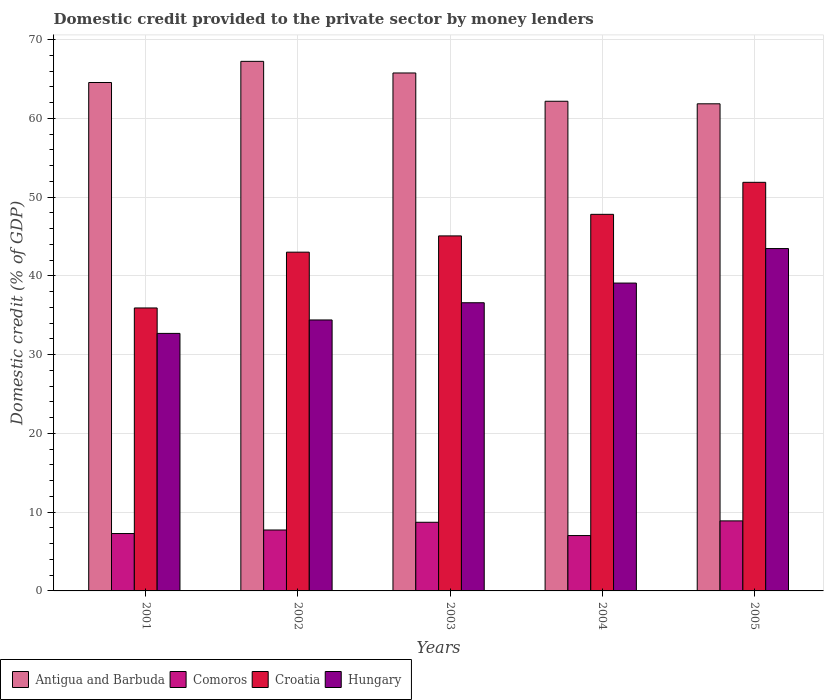How many groups of bars are there?
Your answer should be very brief. 5. Are the number of bars on each tick of the X-axis equal?
Offer a very short reply. Yes. What is the domestic credit provided to the private sector by money lenders in Croatia in 2005?
Your answer should be very brief. 51.88. Across all years, what is the maximum domestic credit provided to the private sector by money lenders in Hungary?
Provide a succinct answer. 43.47. Across all years, what is the minimum domestic credit provided to the private sector by money lenders in Comoros?
Give a very brief answer. 7.03. In which year was the domestic credit provided to the private sector by money lenders in Croatia minimum?
Your answer should be very brief. 2001. What is the total domestic credit provided to the private sector by money lenders in Antigua and Barbuda in the graph?
Keep it short and to the point. 321.6. What is the difference between the domestic credit provided to the private sector by money lenders in Comoros in 2004 and that in 2005?
Make the answer very short. -1.86. What is the difference between the domestic credit provided to the private sector by money lenders in Comoros in 2001 and the domestic credit provided to the private sector by money lenders in Croatia in 2002?
Your answer should be compact. -35.73. What is the average domestic credit provided to the private sector by money lenders in Antigua and Barbuda per year?
Offer a very short reply. 64.32. In the year 2001, what is the difference between the domestic credit provided to the private sector by money lenders in Hungary and domestic credit provided to the private sector by money lenders in Croatia?
Ensure brevity in your answer.  -3.23. In how many years, is the domestic credit provided to the private sector by money lenders in Hungary greater than 66 %?
Offer a very short reply. 0. What is the ratio of the domestic credit provided to the private sector by money lenders in Antigua and Barbuda in 2001 to that in 2005?
Offer a very short reply. 1.04. What is the difference between the highest and the second highest domestic credit provided to the private sector by money lenders in Croatia?
Your answer should be compact. 4.07. What is the difference between the highest and the lowest domestic credit provided to the private sector by money lenders in Comoros?
Give a very brief answer. 1.86. Is it the case that in every year, the sum of the domestic credit provided to the private sector by money lenders in Antigua and Barbuda and domestic credit provided to the private sector by money lenders in Croatia is greater than the sum of domestic credit provided to the private sector by money lenders in Comoros and domestic credit provided to the private sector by money lenders in Hungary?
Your answer should be compact. Yes. What does the 2nd bar from the left in 2001 represents?
Your answer should be compact. Comoros. What does the 1st bar from the right in 2005 represents?
Ensure brevity in your answer.  Hungary. Is it the case that in every year, the sum of the domestic credit provided to the private sector by money lenders in Antigua and Barbuda and domestic credit provided to the private sector by money lenders in Hungary is greater than the domestic credit provided to the private sector by money lenders in Comoros?
Provide a short and direct response. Yes. How many bars are there?
Offer a terse response. 20. Are all the bars in the graph horizontal?
Give a very brief answer. No. Are the values on the major ticks of Y-axis written in scientific E-notation?
Offer a very short reply. No. Where does the legend appear in the graph?
Provide a short and direct response. Bottom left. What is the title of the graph?
Your answer should be very brief. Domestic credit provided to the private sector by money lenders. What is the label or title of the Y-axis?
Your answer should be very brief. Domestic credit (% of GDP). What is the Domestic credit (% of GDP) in Antigua and Barbuda in 2001?
Your answer should be very brief. 64.56. What is the Domestic credit (% of GDP) of Comoros in 2001?
Offer a terse response. 7.29. What is the Domestic credit (% of GDP) in Croatia in 2001?
Your answer should be very brief. 35.93. What is the Domestic credit (% of GDP) of Hungary in 2001?
Your answer should be compact. 32.7. What is the Domestic credit (% of GDP) of Antigua and Barbuda in 2002?
Provide a short and direct response. 67.24. What is the Domestic credit (% of GDP) of Comoros in 2002?
Your answer should be very brief. 7.74. What is the Domestic credit (% of GDP) in Croatia in 2002?
Keep it short and to the point. 43.01. What is the Domestic credit (% of GDP) in Hungary in 2002?
Provide a succinct answer. 34.41. What is the Domestic credit (% of GDP) of Antigua and Barbuda in 2003?
Your answer should be compact. 65.77. What is the Domestic credit (% of GDP) of Comoros in 2003?
Offer a very short reply. 8.72. What is the Domestic credit (% of GDP) in Croatia in 2003?
Give a very brief answer. 45.08. What is the Domestic credit (% of GDP) in Hungary in 2003?
Provide a short and direct response. 36.59. What is the Domestic credit (% of GDP) of Antigua and Barbuda in 2004?
Ensure brevity in your answer.  62.18. What is the Domestic credit (% of GDP) of Comoros in 2004?
Offer a very short reply. 7.03. What is the Domestic credit (% of GDP) of Croatia in 2004?
Ensure brevity in your answer.  47.82. What is the Domestic credit (% of GDP) of Hungary in 2004?
Your answer should be compact. 39.09. What is the Domestic credit (% of GDP) in Antigua and Barbuda in 2005?
Your response must be concise. 61.85. What is the Domestic credit (% of GDP) in Comoros in 2005?
Your answer should be very brief. 8.89. What is the Domestic credit (% of GDP) in Croatia in 2005?
Your response must be concise. 51.88. What is the Domestic credit (% of GDP) of Hungary in 2005?
Provide a short and direct response. 43.47. Across all years, what is the maximum Domestic credit (% of GDP) in Antigua and Barbuda?
Offer a terse response. 67.24. Across all years, what is the maximum Domestic credit (% of GDP) in Comoros?
Ensure brevity in your answer.  8.89. Across all years, what is the maximum Domestic credit (% of GDP) in Croatia?
Your answer should be very brief. 51.88. Across all years, what is the maximum Domestic credit (% of GDP) of Hungary?
Offer a terse response. 43.47. Across all years, what is the minimum Domestic credit (% of GDP) in Antigua and Barbuda?
Provide a short and direct response. 61.85. Across all years, what is the minimum Domestic credit (% of GDP) of Comoros?
Provide a succinct answer. 7.03. Across all years, what is the minimum Domestic credit (% of GDP) of Croatia?
Your answer should be very brief. 35.93. Across all years, what is the minimum Domestic credit (% of GDP) in Hungary?
Provide a short and direct response. 32.7. What is the total Domestic credit (% of GDP) in Antigua and Barbuda in the graph?
Offer a terse response. 321.6. What is the total Domestic credit (% of GDP) of Comoros in the graph?
Keep it short and to the point. 39.66. What is the total Domestic credit (% of GDP) in Croatia in the graph?
Keep it short and to the point. 223.72. What is the total Domestic credit (% of GDP) in Hungary in the graph?
Give a very brief answer. 186.26. What is the difference between the Domestic credit (% of GDP) of Antigua and Barbuda in 2001 and that in 2002?
Provide a short and direct response. -2.69. What is the difference between the Domestic credit (% of GDP) of Comoros in 2001 and that in 2002?
Make the answer very short. -0.45. What is the difference between the Domestic credit (% of GDP) of Croatia in 2001 and that in 2002?
Provide a short and direct response. -7.08. What is the difference between the Domestic credit (% of GDP) in Hungary in 2001 and that in 2002?
Ensure brevity in your answer.  -1.71. What is the difference between the Domestic credit (% of GDP) of Antigua and Barbuda in 2001 and that in 2003?
Offer a very short reply. -1.21. What is the difference between the Domestic credit (% of GDP) in Comoros in 2001 and that in 2003?
Offer a terse response. -1.43. What is the difference between the Domestic credit (% of GDP) of Croatia in 2001 and that in 2003?
Your response must be concise. -9.15. What is the difference between the Domestic credit (% of GDP) of Hungary in 2001 and that in 2003?
Provide a succinct answer. -3.89. What is the difference between the Domestic credit (% of GDP) in Antigua and Barbuda in 2001 and that in 2004?
Provide a succinct answer. 2.38. What is the difference between the Domestic credit (% of GDP) of Comoros in 2001 and that in 2004?
Your answer should be very brief. 0.26. What is the difference between the Domestic credit (% of GDP) of Croatia in 2001 and that in 2004?
Provide a succinct answer. -11.89. What is the difference between the Domestic credit (% of GDP) in Hungary in 2001 and that in 2004?
Keep it short and to the point. -6.39. What is the difference between the Domestic credit (% of GDP) in Antigua and Barbuda in 2001 and that in 2005?
Make the answer very short. 2.7. What is the difference between the Domestic credit (% of GDP) in Comoros in 2001 and that in 2005?
Ensure brevity in your answer.  -1.61. What is the difference between the Domestic credit (% of GDP) of Croatia in 2001 and that in 2005?
Offer a terse response. -15.95. What is the difference between the Domestic credit (% of GDP) of Hungary in 2001 and that in 2005?
Give a very brief answer. -10.77. What is the difference between the Domestic credit (% of GDP) of Antigua and Barbuda in 2002 and that in 2003?
Your answer should be compact. 1.47. What is the difference between the Domestic credit (% of GDP) of Comoros in 2002 and that in 2003?
Provide a short and direct response. -0.98. What is the difference between the Domestic credit (% of GDP) of Croatia in 2002 and that in 2003?
Provide a succinct answer. -2.07. What is the difference between the Domestic credit (% of GDP) of Hungary in 2002 and that in 2003?
Your answer should be compact. -2.19. What is the difference between the Domestic credit (% of GDP) of Antigua and Barbuda in 2002 and that in 2004?
Provide a succinct answer. 5.07. What is the difference between the Domestic credit (% of GDP) of Comoros in 2002 and that in 2004?
Offer a very short reply. 0.71. What is the difference between the Domestic credit (% of GDP) of Croatia in 2002 and that in 2004?
Your response must be concise. -4.8. What is the difference between the Domestic credit (% of GDP) of Hungary in 2002 and that in 2004?
Offer a very short reply. -4.68. What is the difference between the Domestic credit (% of GDP) of Antigua and Barbuda in 2002 and that in 2005?
Your response must be concise. 5.39. What is the difference between the Domestic credit (% of GDP) of Comoros in 2002 and that in 2005?
Your response must be concise. -1.16. What is the difference between the Domestic credit (% of GDP) in Croatia in 2002 and that in 2005?
Offer a very short reply. -8.87. What is the difference between the Domestic credit (% of GDP) in Hungary in 2002 and that in 2005?
Give a very brief answer. -9.07. What is the difference between the Domestic credit (% of GDP) in Antigua and Barbuda in 2003 and that in 2004?
Keep it short and to the point. 3.59. What is the difference between the Domestic credit (% of GDP) of Comoros in 2003 and that in 2004?
Your answer should be very brief. 1.69. What is the difference between the Domestic credit (% of GDP) of Croatia in 2003 and that in 2004?
Provide a succinct answer. -2.74. What is the difference between the Domestic credit (% of GDP) in Hungary in 2003 and that in 2004?
Give a very brief answer. -2.5. What is the difference between the Domestic credit (% of GDP) in Antigua and Barbuda in 2003 and that in 2005?
Your answer should be very brief. 3.91. What is the difference between the Domestic credit (% of GDP) in Comoros in 2003 and that in 2005?
Keep it short and to the point. -0.18. What is the difference between the Domestic credit (% of GDP) of Croatia in 2003 and that in 2005?
Provide a succinct answer. -6.8. What is the difference between the Domestic credit (% of GDP) in Hungary in 2003 and that in 2005?
Keep it short and to the point. -6.88. What is the difference between the Domestic credit (% of GDP) of Antigua and Barbuda in 2004 and that in 2005?
Keep it short and to the point. 0.32. What is the difference between the Domestic credit (% of GDP) of Comoros in 2004 and that in 2005?
Offer a very short reply. -1.86. What is the difference between the Domestic credit (% of GDP) in Croatia in 2004 and that in 2005?
Ensure brevity in your answer.  -4.07. What is the difference between the Domestic credit (% of GDP) of Hungary in 2004 and that in 2005?
Provide a succinct answer. -4.38. What is the difference between the Domestic credit (% of GDP) in Antigua and Barbuda in 2001 and the Domestic credit (% of GDP) in Comoros in 2002?
Ensure brevity in your answer.  56.82. What is the difference between the Domestic credit (% of GDP) of Antigua and Barbuda in 2001 and the Domestic credit (% of GDP) of Croatia in 2002?
Give a very brief answer. 21.54. What is the difference between the Domestic credit (% of GDP) of Antigua and Barbuda in 2001 and the Domestic credit (% of GDP) of Hungary in 2002?
Provide a succinct answer. 30.15. What is the difference between the Domestic credit (% of GDP) in Comoros in 2001 and the Domestic credit (% of GDP) in Croatia in 2002?
Provide a succinct answer. -35.73. What is the difference between the Domestic credit (% of GDP) of Comoros in 2001 and the Domestic credit (% of GDP) of Hungary in 2002?
Ensure brevity in your answer.  -27.12. What is the difference between the Domestic credit (% of GDP) in Croatia in 2001 and the Domestic credit (% of GDP) in Hungary in 2002?
Your answer should be very brief. 1.52. What is the difference between the Domestic credit (% of GDP) in Antigua and Barbuda in 2001 and the Domestic credit (% of GDP) in Comoros in 2003?
Make the answer very short. 55.84. What is the difference between the Domestic credit (% of GDP) of Antigua and Barbuda in 2001 and the Domestic credit (% of GDP) of Croatia in 2003?
Your answer should be very brief. 19.48. What is the difference between the Domestic credit (% of GDP) of Antigua and Barbuda in 2001 and the Domestic credit (% of GDP) of Hungary in 2003?
Offer a very short reply. 27.96. What is the difference between the Domestic credit (% of GDP) of Comoros in 2001 and the Domestic credit (% of GDP) of Croatia in 2003?
Make the answer very short. -37.79. What is the difference between the Domestic credit (% of GDP) of Comoros in 2001 and the Domestic credit (% of GDP) of Hungary in 2003?
Offer a very short reply. -29.31. What is the difference between the Domestic credit (% of GDP) of Croatia in 2001 and the Domestic credit (% of GDP) of Hungary in 2003?
Provide a short and direct response. -0.66. What is the difference between the Domestic credit (% of GDP) in Antigua and Barbuda in 2001 and the Domestic credit (% of GDP) in Comoros in 2004?
Provide a succinct answer. 57.53. What is the difference between the Domestic credit (% of GDP) of Antigua and Barbuda in 2001 and the Domestic credit (% of GDP) of Croatia in 2004?
Give a very brief answer. 16.74. What is the difference between the Domestic credit (% of GDP) in Antigua and Barbuda in 2001 and the Domestic credit (% of GDP) in Hungary in 2004?
Your answer should be compact. 25.47. What is the difference between the Domestic credit (% of GDP) in Comoros in 2001 and the Domestic credit (% of GDP) in Croatia in 2004?
Offer a terse response. -40.53. What is the difference between the Domestic credit (% of GDP) in Comoros in 2001 and the Domestic credit (% of GDP) in Hungary in 2004?
Provide a succinct answer. -31.8. What is the difference between the Domestic credit (% of GDP) of Croatia in 2001 and the Domestic credit (% of GDP) of Hungary in 2004?
Make the answer very short. -3.16. What is the difference between the Domestic credit (% of GDP) in Antigua and Barbuda in 2001 and the Domestic credit (% of GDP) in Comoros in 2005?
Ensure brevity in your answer.  55.66. What is the difference between the Domestic credit (% of GDP) of Antigua and Barbuda in 2001 and the Domestic credit (% of GDP) of Croatia in 2005?
Your answer should be compact. 12.67. What is the difference between the Domestic credit (% of GDP) of Antigua and Barbuda in 2001 and the Domestic credit (% of GDP) of Hungary in 2005?
Offer a terse response. 21.08. What is the difference between the Domestic credit (% of GDP) in Comoros in 2001 and the Domestic credit (% of GDP) in Croatia in 2005?
Make the answer very short. -44.6. What is the difference between the Domestic credit (% of GDP) of Comoros in 2001 and the Domestic credit (% of GDP) of Hungary in 2005?
Provide a succinct answer. -36.19. What is the difference between the Domestic credit (% of GDP) in Croatia in 2001 and the Domestic credit (% of GDP) in Hungary in 2005?
Your response must be concise. -7.54. What is the difference between the Domestic credit (% of GDP) of Antigua and Barbuda in 2002 and the Domestic credit (% of GDP) of Comoros in 2003?
Keep it short and to the point. 58.53. What is the difference between the Domestic credit (% of GDP) in Antigua and Barbuda in 2002 and the Domestic credit (% of GDP) in Croatia in 2003?
Make the answer very short. 22.16. What is the difference between the Domestic credit (% of GDP) in Antigua and Barbuda in 2002 and the Domestic credit (% of GDP) in Hungary in 2003?
Ensure brevity in your answer.  30.65. What is the difference between the Domestic credit (% of GDP) of Comoros in 2002 and the Domestic credit (% of GDP) of Croatia in 2003?
Make the answer very short. -37.34. What is the difference between the Domestic credit (% of GDP) in Comoros in 2002 and the Domestic credit (% of GDP) in Hungary in 2003?
Offer a very short reply. -28.86. What is the difference between the Domestic credit (% of GDP) of Croatia in 2002 and the Domestic credit (% of GDP) of Hungary in 2003?
Your answer should be very brief. 6.42. What is the difference between the Domestic credit (% of GDP) in Antigua and Barbuda in 2002 and the Domestic credit (% of GDP) in Comoros in 2004?
Ensure brevity in your answer.  60.21. What is the difference between the Domestic credit (% of GDP) in Antigua and Barbuda in 2002 and the Domestic credit (% of GDP) in Croatia in 2004?
Your response must be concise. 19.43. What is the difference between the Domestic credit (% of GDP) in Antigua and Barbuda in 2002 and the Domestic credit (% of GDP) in Hungary in 2004?
Keep it short and to the point. 28.15. What is the difference between the Domestic credit (% of GDP) in Comoros in 2002 and the Domestic credit (% of GDP) in Croatia in 2004?
Keep it short and to the point. -40.08. What is the difference between the Domestic credit (% of GDP) of Comoros in 2002 and the Domestic credit (% of GDP) of Hungary in 2004?
Ensure brevity in your answer.  -31.35. What is the difference between the Domestic credit (% of GDP) of Croatia in 2002 and the Domestic credit (% of GDP) of Hungary in 2004?
Keep it short and to the point. 3.92. What is the difference between the Domestic credit (% of GDP) in Antigua and Barbuda in 2002 and the Domestic credit (% of GDP) in Comoros in 2005?
Your answer should be compact. 58.35. What is the difference between the Domestic credit (% of GDP) in Antigua and Barbuda in 2002 and the Domestic credit (% of GDP) in Croatia in 2005?
Keep it short and to the point. 15.36. What is the difference between the Domestic credit (% of GDP) in Antigua and Barbuda in 2002 and the Domestic credit (% of GDP) in Hungary in 2005?
Your answer should be very brief. 23.77. What is the difference between the Domestic credit (% of GDP) in Comoros in 2002 and the Domestic credit (% of GDP) in Croatia in 2005?
Your answer should be very brief. -44.15. What is the difference between the Domestic credit (% of GDP) in Comoros in 2002 and the Domestic credit (% of GDP) in Hungary in 2005?
Keep it short and to the point. -35.74. What is the difference between the Domestic credit (% of GDP) of Croatia in 2002 and the Domestic credit (% of GDP) of Hungary in 2005?
Make the answer very short. -0.46. What is the difference between the Domestic credit (% of GDP) in Antigua and Barbuda in 2003 and the Domestic credit (% of GDP) in Comoros in 2004?
Offer a terse response. 58.74. What is the difference between the Domestic credit (% of GDP) of Antigua and Barbuda in 2003 and the Domestic credit (% of GDP) of Croatia in 2004?
Provide a succinct answer. 17.95. What is the difference between the Domestic credit (% of GDP) in Antigua and Barbuda in 2003 and the Domestic credit (% of GDP) in Hungary in 2004?
Your answer should be compact. 26.68. What is the difference between the Domestic credit (% of GDP) in Comoros in 2003 and the Domestic credit (% of GDP) in Croatia in 2004?
Give a very brief answer. -39.1. What is the difference between the Domestic credit (% of GDP) in Comoros in 2003 and the Domestic credit (% of GDP) in Hungary in 2004?
Your response must be concise. -30.37. What is the difference between the Domestic credit (% of GDP) in Croatia in 2003 and the Domestic credit (% of GDP) in Hungary in 2004?
Your answer should be compact. 5.99. What is the difference between the Domestic credit (% of GDP) in Antigua and Barbuda in 2003 and the Domestic credit (% of GDP) in Comoros in 2005?
Provide a short and direct response. 56.88. What is the difference between the Domestic credit (% of GDP) of Antigua and Barbuda in 2003 and the Domestic credit (% of GDP) of Croatia in 2005?
Provide a short and direct response. 13.89. What is the difference between the Domestic credit (% of GDP) of Antigua and Barbuda in 2003 and the Domestic credit (% of GDP) of Hungary in 2005?
Offer a very short reply. 22.3. What is the difference between the Domestic credit (% of GDP) in Comoros in 2003 and the Domestic credit (% of GDP) in Croatia in 2005?
Make the answer very short. -43.17. What is the difference between the Domestic credit (% of GDP) of Comoros in 2003 and the Domestic credit (% of GDP) of Hungary in 2005?
Provide a short and direct response. -34.76. What is the difference between the Domestic credit (% of GDP) of Croatia in 2003 and the Domestic credit (% of GDP) of Hungary in 2005?
Offer a very short reply. 1.61. What is the difference between the Domestic credit (% of GDP) of Antigua and Barbuda in 2004 and the Domestic credit (% of GDP) of Comoros in 2005?
Make the answer very short. 53.28. What is the difference between the Domestic credit (% of GDP) of Antigua and Barbuda in 2004 and the Domestic credit (% of GDP) of Croatia in 2005?
Offer a very short reply. 10.29. What is the difference between the Domestic credit (% of GDP) of Antigua and Barbuda in 2004 and the Domestic credit (% of GDP) of Hungary in 2005?
Ensure brevity in your answer.  18.7. What is the difference between the Domestic credit (% of GDP) of Comoros in 2004 and the Domestic credit (% of GDP) of Croatia in 2005?
Keep it short and to the point. -44.85. What is the difference between the Domestic credit (% of GDP) in Comoros in 2004 and the Domestic credit (% of GDP) in Hungary in 2005?
Keep it short and to the point. -36.44. What is the difference between the Domestic credit (% of GDP) of Croatia in 2004 and the Domestic credit (% of GDP) of Hungary in 2005?
Keep it short and to the point. 4.34. What is the average Domestic credit (% of GDP) of Antigua and Barbuda per year?
Keep it short and to the point. 64.32. What is the average Domestic credit (% of GDP) of Comoros per year?
Make the answer very short. 7.93. What is the average Domestic credit (% of GDP) of Croatia per year?
Ensure brevity in your answer.  44.74. What is the average Domestic credit (% of GDP) in Hungary per year?
Make the answer very short. 37.25. In the year 2001, what is the difference between the Domestic credit (% of GDP) of Antigua and Barbuda and Domestic credit (% of GDP) of Comoros?
Offer a terse response. 57.27. In the year 2001, what is the difference between the Domestic credit (% of GDP) in Antigua and Barbuda and Domestic credit (% of GDP) in Croatia?
Your answer should be compact. 28.63. In the year 2001, what is the difference between the Domestic credit (% of GDP) in Antigua and Barbuda and Domestic credit (% of GDP) in Hungary?
Keep it short and to the point. 31.86. In the year 2001, what is the difference between the Domestic credit (% of GDP) in Comoros and Domestic credit (% of GDP) in Croatia?
Your response must be concise. -28.64. In the year 2001, what is the difference between the Domestic credit (% of GDP) in Comoros and Domestic credit (% of GDP) in Hungary?
Provide a succinct answer. -25.41. In the year 2001, what is the difference between the Domestic credit (% of GDP) of Croatia and Domestic credit (% of GDP) of Hungary?
Your answer should be very brief. 3.23. In the year 2002, what is the difference between the Domestic credit (% of GDP) of Antigua and Barbuda and Domestic credit (% of GDP) of Comoros?
Offer a terse response. 59.51. In the year 2002, what is the difference between the Domestic credit (% of GDP) of Antigua and Barbuda and Domestic credit (% of GDP) of Croatia?
Make the answer very short. 24.23. In the year 2002, what is the difference between the Domestic credit (% of GDP) in Antigua and Barbuda and Domestic credit (% of GDP) in Hungary?
Offer a terse response. 32.84. In the year 2002, what is the difference between the Domestic credit (% of GDP) of Comoros and Domestic credit (% of GDP) of Croatia?
Your answer should be compact. -35.28. In the year 2002, what is the difference between the Domestic credit (% of GDP) in Comoros and Domestic credit (% of GDP) in Hungary?
Your answer should be compact. -26.67. In the year 2002, what is the difference between the Domestic credit (% of GDP) in Croatia and Domestic credit (% of GDP) in Hungary?
Provide a succinct answer. 8.61. In the year 2003, what is the difference between the Domestic credit (% of GDP) in Antigua and Barbuda and Domestic credit (% of GDP) in Comoros?
Offer a terse response. 57.05. In the year 2003, what is the difference between the Domestic credit (% of GDP) in Antigua and Barbuda and Domestic credit (% of GDP) in Croatia?
Offer a terse response. 20.69. In the year 2003, what is the difference between the Domestic credit (% of GDP) in Antigua and Barbuda and Domestic credit (% of GDP) in Hungary?
Make the answer very short. 29.18. In the year 2003, what is the difference between the Domestic credit (% of GDP) of Comoros and Domestic credit (% of GDP) of Croatia?
Your response must be concise. -36.36. In the year 2003, what is the difference between the Domestic credit (% of GDP) of Comoros and Domestic credit (% of GDP) of Hungary?
Offer a very short reply. -27.88. In the year 2003, what is the difference between the Domestic credit (% of GDP) in Croatia and Domestic credit (% of GDP) in Hungary?
Your response must be concise. 8.49. In the year 2004, what is the difference between the Domestic credit (% of GDP) in Antigua and Barbuda and Domestic credit (% of GDP) in Comoros?
Your answer should be very brief. 55.14. In the year 2004, what is the difference between the Domestic credit (% of GDP) of Antigua and Barbuda and Domestic credit (% of GDP) of Croatia?
Offer a very short reply. 14.36. In the year 2004, what is the difference between the Domestic credit (% of GDP) in Antigua and Barbuda and Domestic credit (% of GDP) in Hungary?
Your response must be concise. 23.09. In the year 2004, what is the difference between the Domestic credit (% of GDP) of Comoros and Domestic credit (% of GDP) of Croatia?
Your answer should be very brief. -40.79. In the year 2004, what is the difference between the Domestic credit (% of GDP) in Comoros and Domestic credit (% of GDP) in Hungary?
Give a very brief answer. -32.06. In the year 2004, what is the difference between the Domestic credit (% of GDP) of Croatia and Domestic credit (% of GDP) of Hungary?
Offer a terse response. 8.73. In the year 2005, what is the difference between the Domestic credit (% of GDP) in Antigua and Barbuda and Domestic credit (% of GDP) in Comoros?
Make the answer very short. 52.96. In the year 2005, what is the difference between the Domestic credit (% of GDP) of Antigua and Barbuda and Domestic credit (% of GDP) of Croatia?
Offer a terse response. 9.97. In the year 2005, what is the difference between the Domestic credit (% of GDP) in Antigua and Barbuda and Domestic credit (% of GDP) in Hungary?
Provide a succinct answer. 18.38. In the year 2005, what is the difference between the Domestic credit (% of GDP) of Comoros and Domestic credit (% of GDP) of Croatia?
Keep it short and to the point. -42.99. In the year 2005, what is the difference between the Domestic credit (% of GDP) of Comoros and Domestic credit (% of GDP) of Hungary?
Your answer should be very brief. -34.58. In the year 2005, what is the difference between the Domestic credit (% of GDP) in Croatia and Domestic credit (% of GDP) in Hungary?
Provide a succinct answer. 8.41. What is the ratio of the Domestic credit (% of GDP) in Antigua and Barbuda in 2001 to that in 2002?
Provide a short and direct response. 0.96. What is the ratio of the Domestic credit (% of GDP) of Comoros in 2001 to that in 2002?
Offer a very short reply. 0.94. What is the ratio of the Domestic credit (% of GDP) of Croatia in 2001 to that in 2002?
Offer a terse response. 0.84. What is the ratio of the Domestic credit (% of GDP) in Hungary in 2001 to that in 2002?
Make the answer very short. 0.95. What is the ratio of the Domestic credit (% of GDP) of Antigua and Barbuda in 2001 to that in 2003?
Your answer should be very brief. 0.98. What is the ratio of the Domestic credit (% of GDP) in Comoros in 2001 to that in 2003?
Your answer should be very brief. 0.84. What is the ratio of the Domestic credit (% of GDP) of Croatia in 2001 to that in 2003?
Give a very brief answer. 0.8. What is the ratio of the Domestic credit (% of GDP) of Hungary in 2001 to that in 2003?
Give a very brief answer. 0.89. What is the ratio of the Domestic credit (% of GDP) in Antigua and Barbuda in 2001 to that in 2004?
Give a very brief answer. 1.04. What is the ratio of the Domestic credit (% of GDP) of Comoros in 2001 to that in 2004?
Your answer should be compact. 1.04. What is the ratio of the Domestic credit (% of GDP) of Croatia in 2001 to that in 2004?
Offer a terse response. 0.75. What is the ratio of the Domestic credit (% of GDP) of Hungary in 2001 to that in 2004?
Provide a short and direct response. 0.84. What is the ratio of the Domestic credit (% of GDP) in Antigua and Barbuda in 2001 to that in 2005?
Give a very brief answer. 1.04. What is the ratio of the Domestic credit (% of GDP) of Comoros in 2001 to that in 2005?
Offer a terse response. 0.82. What is the ratio of the Domestic credit (% of GDP) in Croatia in 2001 to that in 2005?
Your answer should be very brief. 0.69. What is the ratio of the Domestic credit (% of GDP) of Hungary in 2001 to that in 2005?
Provide a succinct answer. 0.75. What is the ratio of the Domestic credit (% of GDP) in Antigua and Barbuda in 2002 to that in 2003?
Your answer should be very brief. 1.02. What is the ratio of the Domestic credit (% of GDP) of Comoros in 2002 to that in 2003?
Make the answer very short. 0.89. What is the ratio of the Domestic credit (% of GDP) in Croatia in 2002 to that in 2003?
Offer a very short reply. 0.95. What is the ratio of the Domestic credit (% of GDP) in Hungary in 2002 to that in 2003?
Your answer should be compact. 0.94. What is the ratio of the Domestic credit (% of GDP) of Antigua and Barbuda in 2002 to that in 2004?
Keep it short and to the point. 1.08. What is the ratio of the Domestic credit (% of GDP) in Comoros in 2002 to that in 2004?
Make the answer very short. 1.1. What is the ratio of the Domestic credit (% of GDP) in Croatia in 2002 to that in 2004?
Provide a short and direct response. 0.9. What is the ratio of the Domestic credit (% of GDP) of Hungary in 2002 to that in 2004?
Your answer should be very brief. 0.88. What is the ratio of the Domestic credit (% of GDP) of Antigua and Barbuda in 2002 to that in 2005?
Your response must be concise. 1.09. What is the ratio of the Domestic credit (% of GDP) in Comoros in 2002 to that in 2005?
Offer a very short reply. 0.87. What is the ratio of the Domestic credit (% of GDP) of Croatia in 2002 to that in 2005?
Give a very brief answer. 0.83. What is the ratio of the Domestic credit (% of GDP) of Hungary in 2002 to that in 2005?
Provide a succinct answer. 0.79. What is the ratio of the Domestic credit (% of GDP) of Antigua and Barbuda in 2003 to that in 2004?
Your response must be concise. 1.06. What is the ratio of the Domestic credit (% of GDP) of Comoros in 2003 to that in 2004?
Provide a short and direct response. 1.24. What is the ratio of the Domestic credit (% of GDP) of Croatia in 2003 to that in 2004?
Make the answer very short. 0.94. What is the ratio of the Domestic credit (% of GDP) in Hungary in 2003 to that in 2004?
Your response must be concise. 0.94. What is the ratio of the Domestic credit (% of GDP) in Antigua and Barbuda in 2003 to that in 2005?
Your answer should be very brief. 1.06. What is the ratio of the Domestic credit (% of GDP) in Comoros in 2003 to that in 2005?
Provide a succinct answer. 0.98. What is the ratio of the Domestic credit (% of GDP) of Croatia in 2003 to that in 2005?
Make the answer very short. 0.87. What is the ratio of the Domestic credit (% of GDP) in Hungary in 2003 to that in 2005?
Ensure brevity in your answer.  0.84. What is the ratio of the Domestic credit (% of GDP) in Comoros in 2004 to that in 2005?
Offer a terse response. 0.79. What is the ratio of the Domestic credit (% of GDP) of Croatia in 2004 to that in 2005?
Offer a very short reply. 0.92. What is the ratio of the Domestic credit (% of GDP) of Hungary in 2004 to that in 2005?
Make the answer very short. 0.9. What is the difference between the highest and the second highest Domestic credit (% of GDP) of Antigua and Barbuda?
Give a very brief answer. 1.47. What is the difference between the highest and the second highest Domestic credit (% of GDP) of Comoros?
Ensure brevity in your answer.  0.18. What is the difference between the highest and the second highest Domestic credit (% of GDP) of Croatia?
Your answer should be very brief. 4.07. What is the difference between the highest and the second highest Domestic credit (% of GDP) of Hungary?
Ensure brevity in your answer.  4.38. What is the difference between the highest and the lowest Domestic credit (% of GDP) of Antigua and Barbuda?
Give a very brief answer. 5.39. What is the difference between the highest and the lowest Domestic credit (% of GDP) in Comoros?
Your answer should be very brief. 1.86. What is the difference between the highest and the lowest Domestic credit (% of GDP) in Croatia?
Offer a very short reply. 15.95. What is the difference between the highest and the lowest Domestic credit (% of GDP) of Hungary?
Keep it short and to the point. 10.77. 